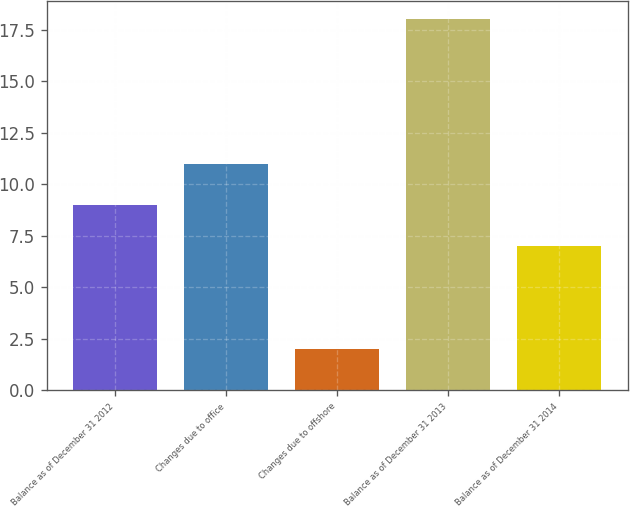Convert chart to OTSL. <chart><loc_0><loc_0><loc_500><loc_500><bar_chart><fcel>Balance as of December 31 2012<fcel>Changes due to office<fcel>Changes due to offshore<fcel>Balance as of December 31 2013<fcel>Balance as of December 31 2014<nl><fcel>9<fcel>11<fcel>2<fcel>18<fcel>7<nl></chart> 